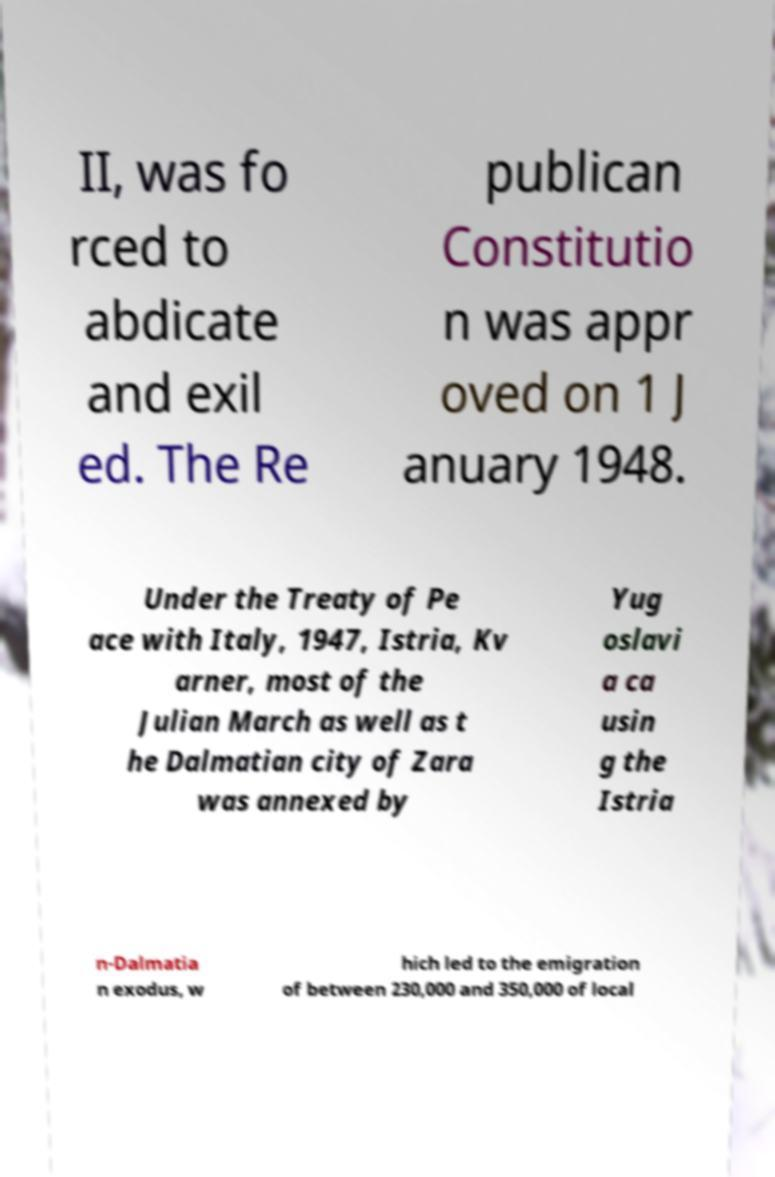Can you read and provide the text displayed in the image?This photo seems to have some interesting text. Can you extract and type it out for me? II, was fo rced to abdicate and exil ed. The Re publican Constitutio n was appr oved on 1 J anuary 1948. Under the Treaty of Pe ace with Italy, 1947, Istria, Kv arner, most of the Julian March as well as t he Dalmatian city of Zara was annexed by Yug oslavi a ca usin g the Istria n-Dalmatia n exodus, w hich led to the emigration of between 230,000 and 350,000 of local 